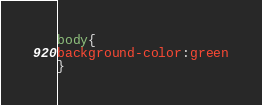<code> <loc_0><loc_0><loc_500><loc_500><_CSS_>body{
background-color:green
}
</code> 